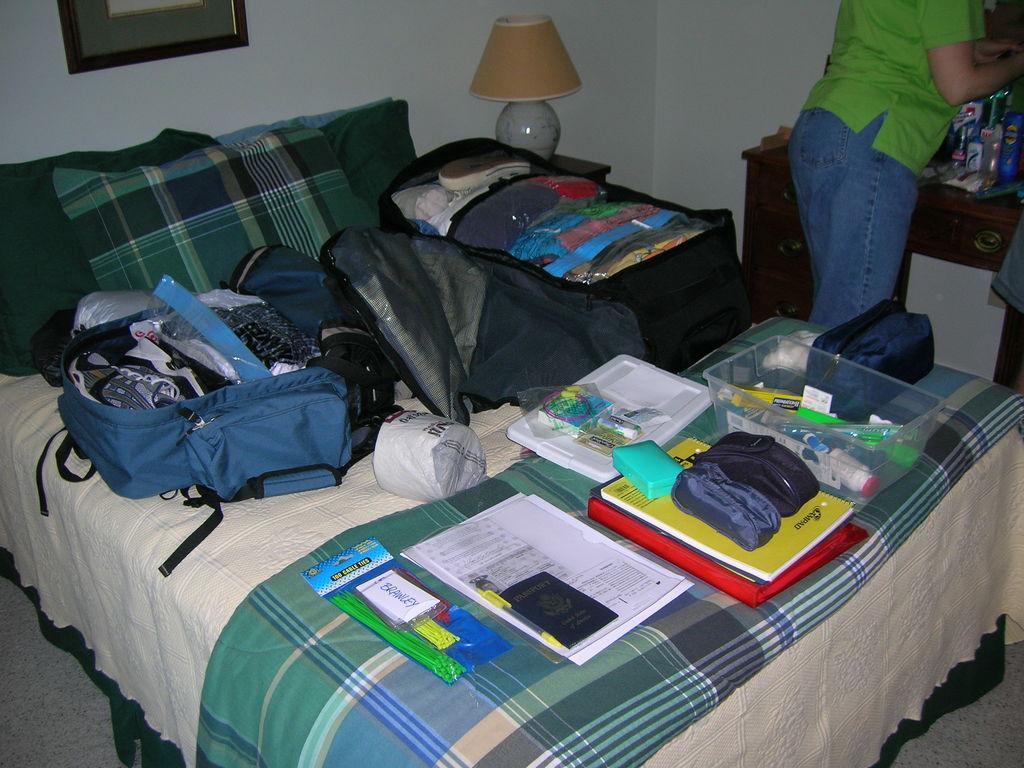Please provide a concise description of this image. In the center of the image there is a bed on which there are many objects like suitcase,clothes,papers,box. In the background of the image there is a wall. There is a photo frame. There is a lamp. To the right side of the image there is a person,table. At the bottom of the image there is floor. 